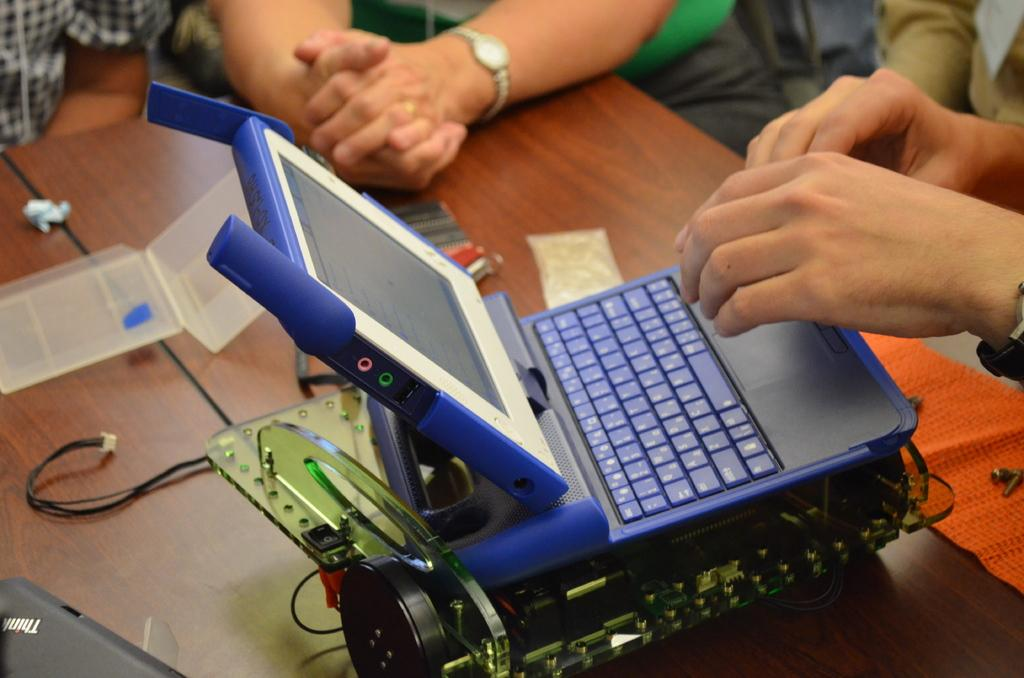What type of electronic device is on the table in the image? There is a small laptop on the table. What else is present on the table besides the laptop? There is an electronic object, cables, a mat, and other objects on the table. How are the people in the image positioned? There are people sitting on chairs beside the table. Is there a volcano erupting in the background of the image? No, there is no volcano or any indication of an eruption in the image. 